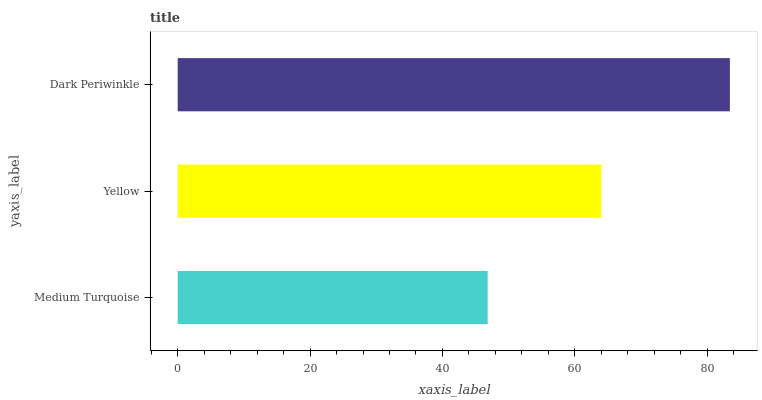Is Medium Turquoise the minimum?
Answer yes or no. Yes. Is Dark Periwinkle the maximum?
Answer yes or no. Yes. Is Yellow the minimum?
Answer yes or no. No. Is Yellow the maximum?
Answer yes or no. No. Is Yellow greater than Medium Turquoise?
Answer yes or no. Yes. Is Medium Turquoise less than Yellow?
Answer yes or no. Yes. Is Medium Turquoise greater than Yellow?
Answer yes or no. No. Is Yellow less than Medium Turquoise?
Answer yes or no. No. Is Yellow the high median?
Answer yes or no. Yes. Is Yellow the low median?
Answer yes or no. Yes. Is Medium Turquoise the high median?
Answer yes or no. No. Is Dark Periwinkle the low median?
Answer yes or no. No. 